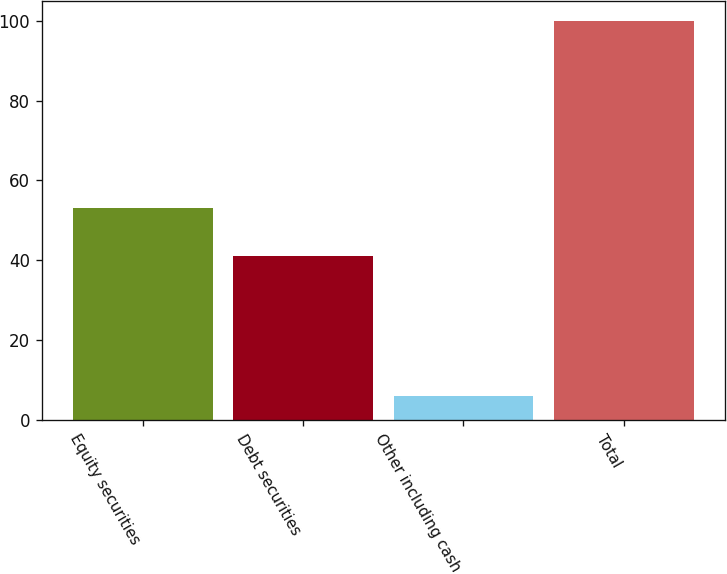Convert chart. <chart><loc_0><loc_0><loc_500><loc_500><bar_chart><fcel>Equity securities<fcel>Debt securities<fcel>Other including cash<fcel>Total<nl><fcel>53<fcel>41<fcel>6<fcel>100<nl></chart> 